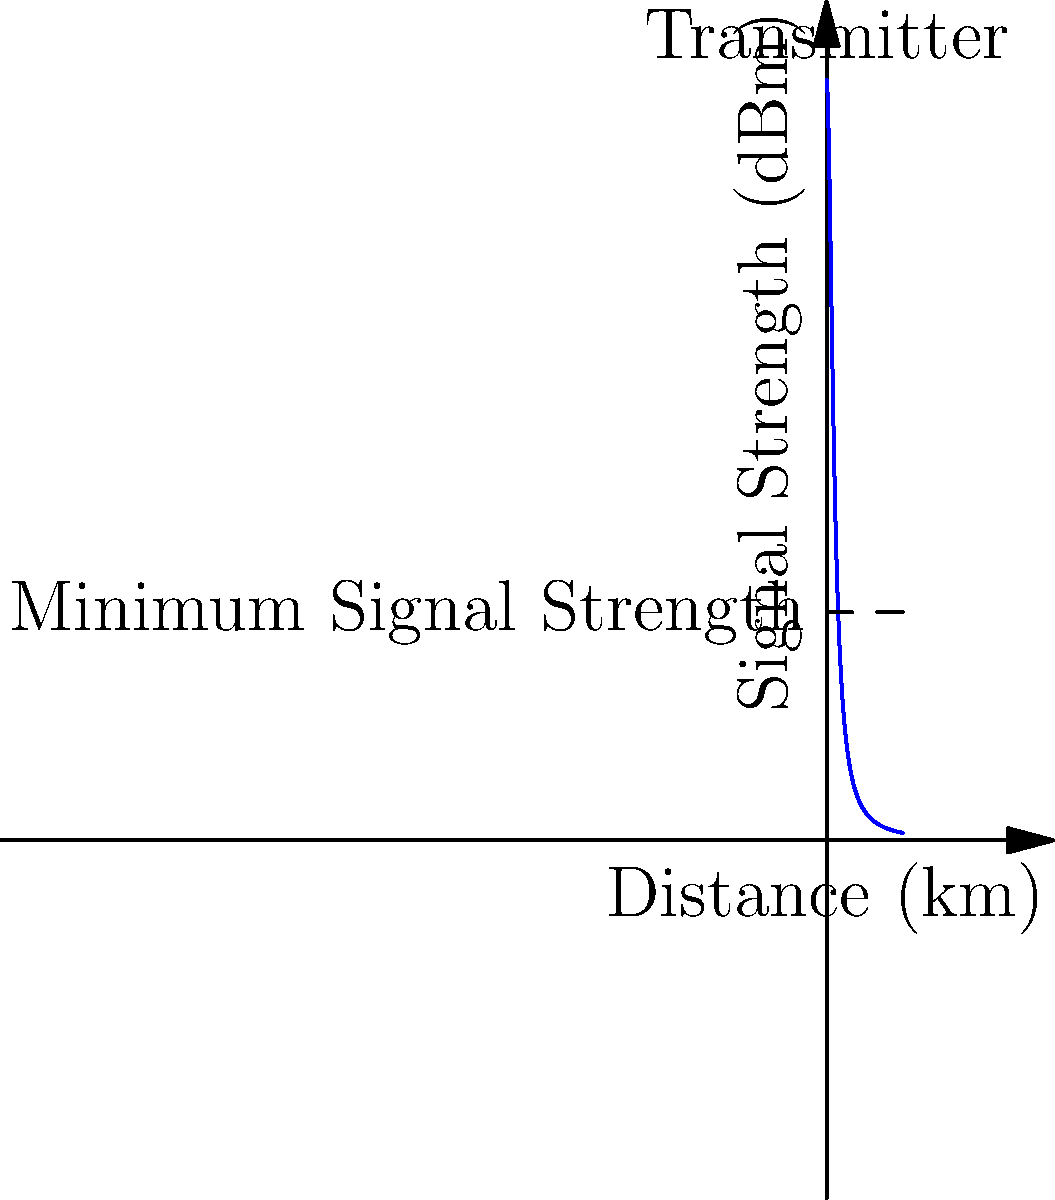Your local radio station is upgrading its transmitter. The graph shows the signal strength (in dBm) as a function of distance from the transmitter (in km). If the minimum signal strength required for clear reception is 30 dBm, what is the maximum coverage radius of the transmitter? To find the maximum coverage radius, we need to determine where the signal strength curve intersects the minimum required signal strength line. Let's approach this step-by-step:

1) The signal strength function is given by:
   $$S(x) = \frac{100}{1 + x^2}$$
   where $S$ is the signal strength in dBm and $x$ is the distance in km.

2) We need to find $x$ when $S(x) = 30$ dBm:
   $$30 = \frac{100}{1 + x^2}$$

3) Multiply both sides by $(1 + x^2)$:
   $$30(1 + x^2) = 100$$

4) Expand the left side:
   $$30 + 30x^2 = 100$$

5) Subtract 30 from both sides:
   $$30x^2 = 70$$

6) Divide both sides by 30:
   $$x^2 = \frac{70}{30} \approx 2.33$$

7) Take the square root of both sides:
   $$x = \sqrt{\frac{70}{30}} \approx 1.53$$

Therefore, the maximum coverage radius is approximately 1.53 km.
Answer: 1.53 km 